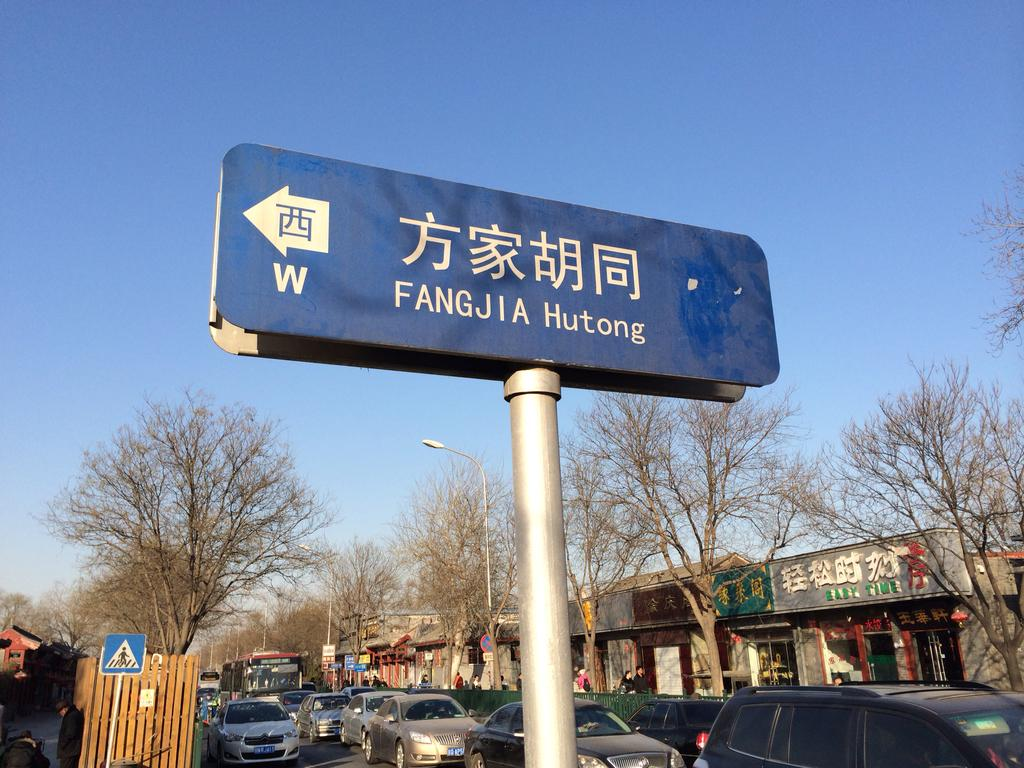What structures are on poles in the image? There are boards on poles in the image. What type of barrier can be seen in the image? There is a fence in the image. What type of transportation is visible on the road in the image? Vehicles are present on the road in the image. What can be seen in the distance in the image? There are buildings and trees visible in the background of the image. What type of lighting is present in the background of the image? There are lights on poles in the background of the image. What is the color of the sky in the image? The sky is blue in the image. Can you see the tongue of the person in the image? There is no person present in the image, so there is no tongue to see. 